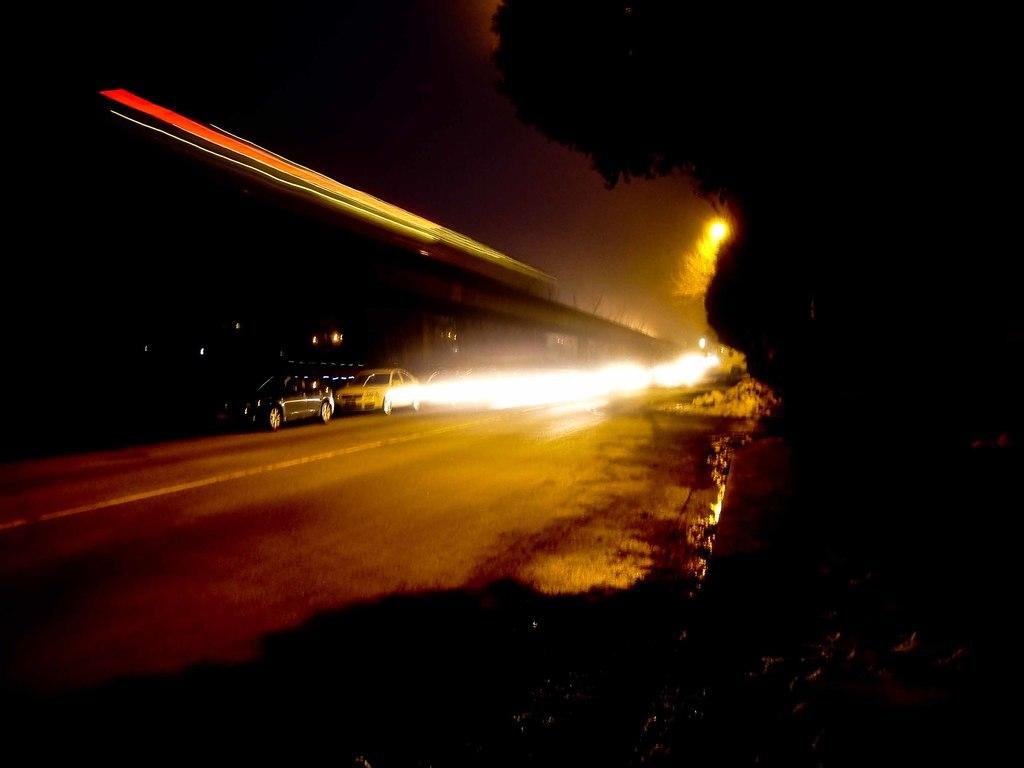What is the overall appearance of the image? The image has a dark appearance. What type of natural elements can be seen in the image? There are trees in the image. What man-made structures are present in the image? There is a road, vehicles, a bridge, and lights visible in the image. How many types of man-made structures can be identified in the image? There are three types of man-made structures: a road, vehicles, and a bridge. What can be seen in the background of the image? The sky in the background appears dark. How many fish can be seen swimming in the image? There are no fish present in the image. What type of sofa is visible in the image? There is no sofa present in the image. 